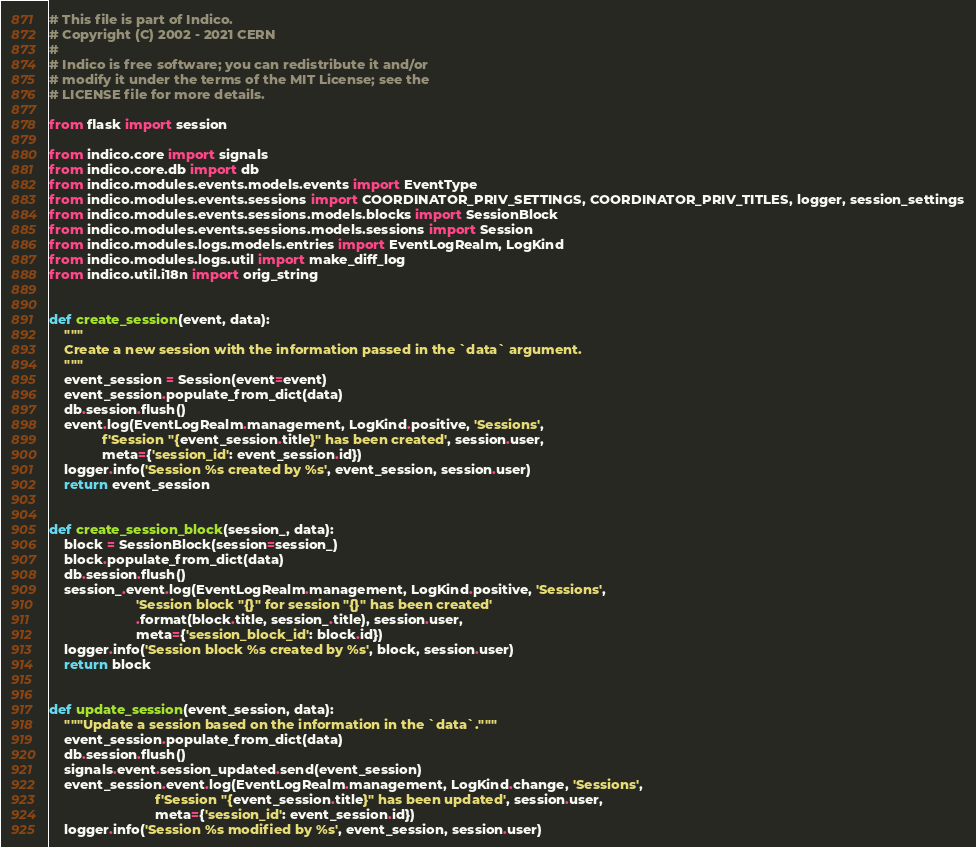<code> <loc_0><loc_0><loc_500><loc_500><_Python_># This file is part of Indico.
# Copyright (C) 2002 - 2021 CERN
#
# Indico is free software; you can redistribute it and/or
# modify it under the terms of the MIT License; see the
# LICENSE file for more details.

from flask import session

from indico.core import signals
from indico.core.db import db
from indico.modules.events.models.events import EventType
from indico.modules.events.sessions import COORDINATOR_PRIV_SETTINGS, COORDINATOR_PRIV_TITLES, logger, session_settings
from indico.modules.events.sessions.models.blocks import SessionBlock
from indico.modules.events.sessions.models.sessions import Session
from indico.modules.logs.models.entries import EventLogRealm, LogKind
from indico.modules.logs.util import make_diff_log
from indico.util.i18n import orig_string


def create_session(event, data):
    """
    Create a new session with the information passed in the `data` argument.
    """
    event_session = Session(event=event)
    event_session.populate_from_dict(data)
    db.session.flush()
    event.log(EventLogRealm.management, LogKind.positive, 'Sessions',
              f'Session "{event_session.title}" has been created', session.user,
              meta={'session_id': event_session.id})
    logger.info('Session %s created by %s', event_session, session.user)
    return event_session


def create_session_block(session_, data):
    block = SessionBlock(session=session_)
    block.populate_from_dict(data)
    db.session.flush()
    session_.event.log(EventLogRealm.management, LogKind.positive, 'Sessions',
                       'Session block "{}" for session "{}" has been created'
                       .format(block.title, session_.title), session.user,
                       meta={'session_block_id': block.id})
    logger.info('Session block %s created by %s', block, session.user)
    return block


def update_session(event_session, data):
    """Update a session based on the information in the `data`."""
    event_session.populate_from_dict(data)
    db.session.flush()
    signals.event.session_updated.send(event_session)
    event_session.event.log(EventLogRealm.management, LogKind.change, 'Sessions',
                            f'Session "{event_session.title}" has been updated', session.user,
                            meta={'session_id': event_session.id})
    logger.info('Session %s modified by %s', event_session, session.user)

</code> 